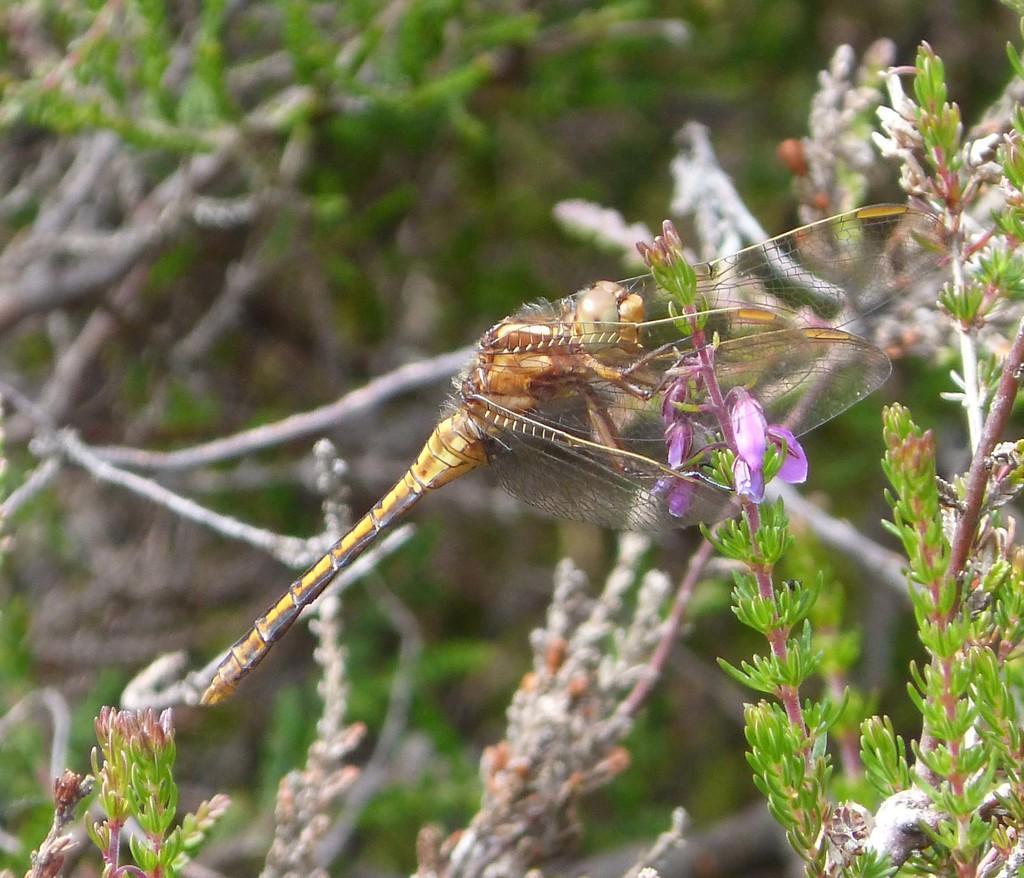Describe this image in one or two sentences. In this image I can see an insect which is in brown and cream color on the plant and the plant is in green color. 